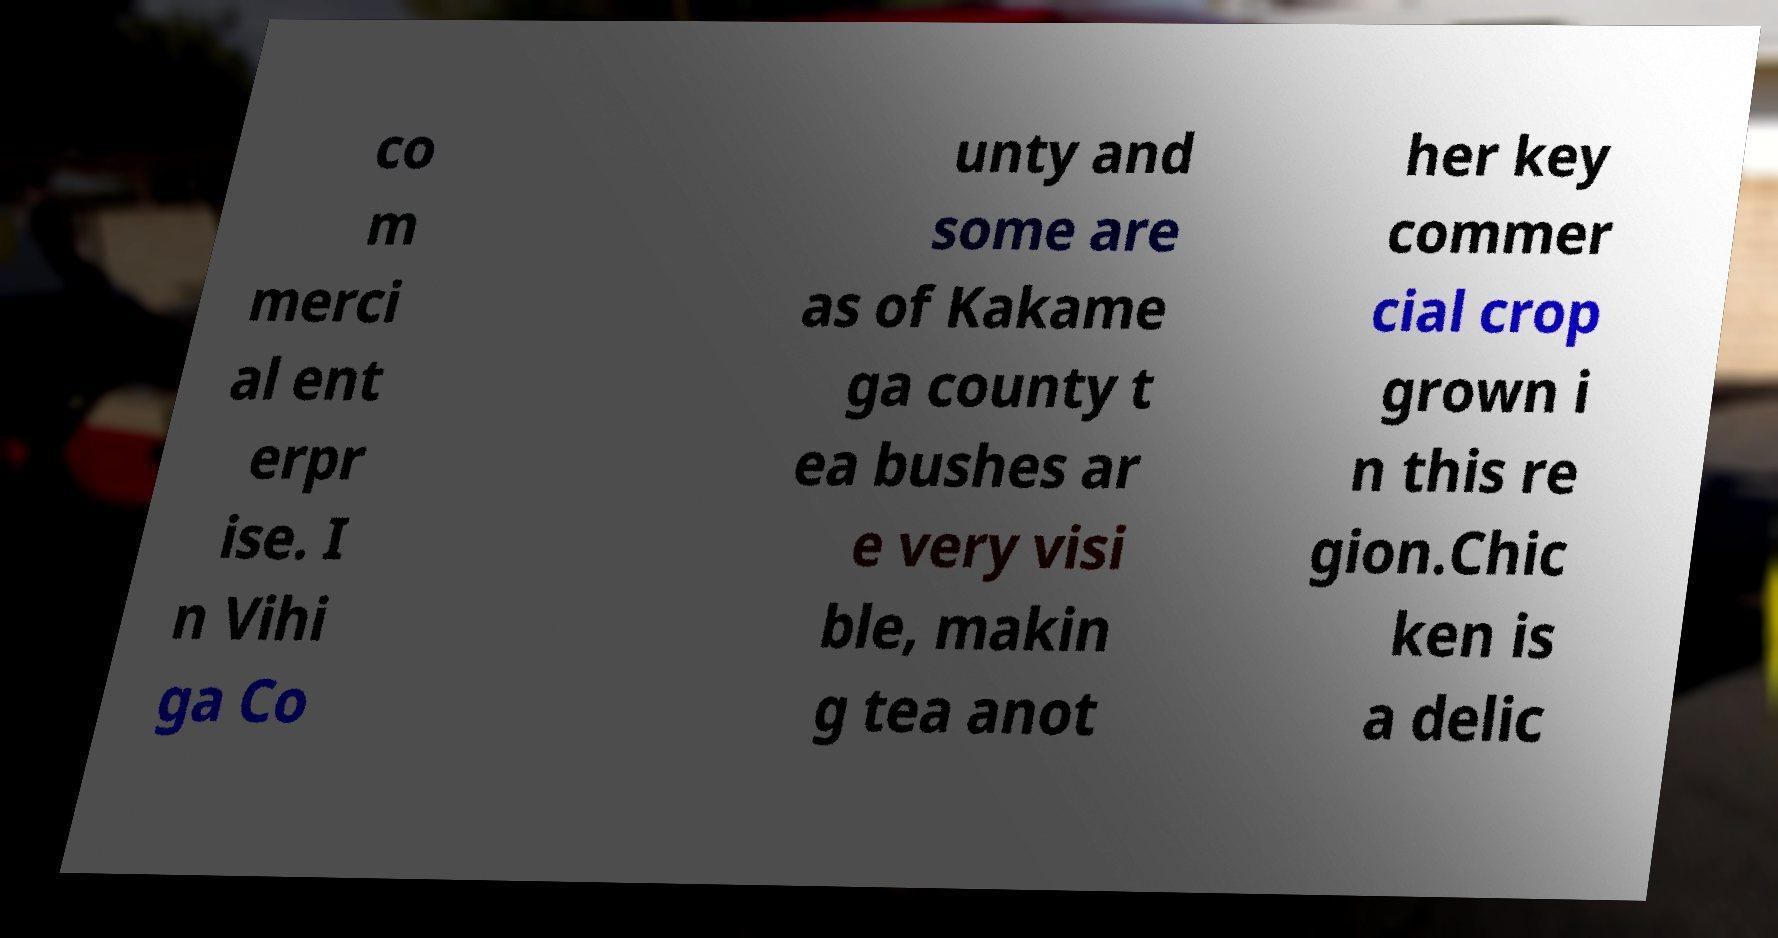Can you accurately transcribe the text from the provided image for me? co m merci al ent erpr ise. I n Vihi ga Co unty and some are as of Kakame ga county t ea bushes ar e very visi ble, makin g tea anot her key commer cial crop grown i n this re gion.Chic ken is a delic 